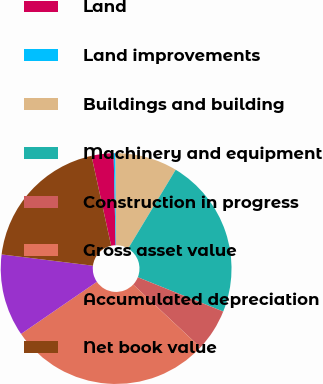Convert chart. <chart><loc_0><loc_0><loc_500><loc_500><pie_chart><fcel>Land<fcel>Land improvements<fcel>Buildings and building<fcel>Machinery and equipment<fcel>Construction in progress<fcel>Gross asset value<fcel>Accumulated depreciation<fcel>Net book value<nl><fcel>3.08%<fcel>0.26%<fcel>8.72%<fcel>22.44%<fcel>5.9%<fcel>28.44%<fcel>11.54%<fcel>19.62%<nl></chart> 